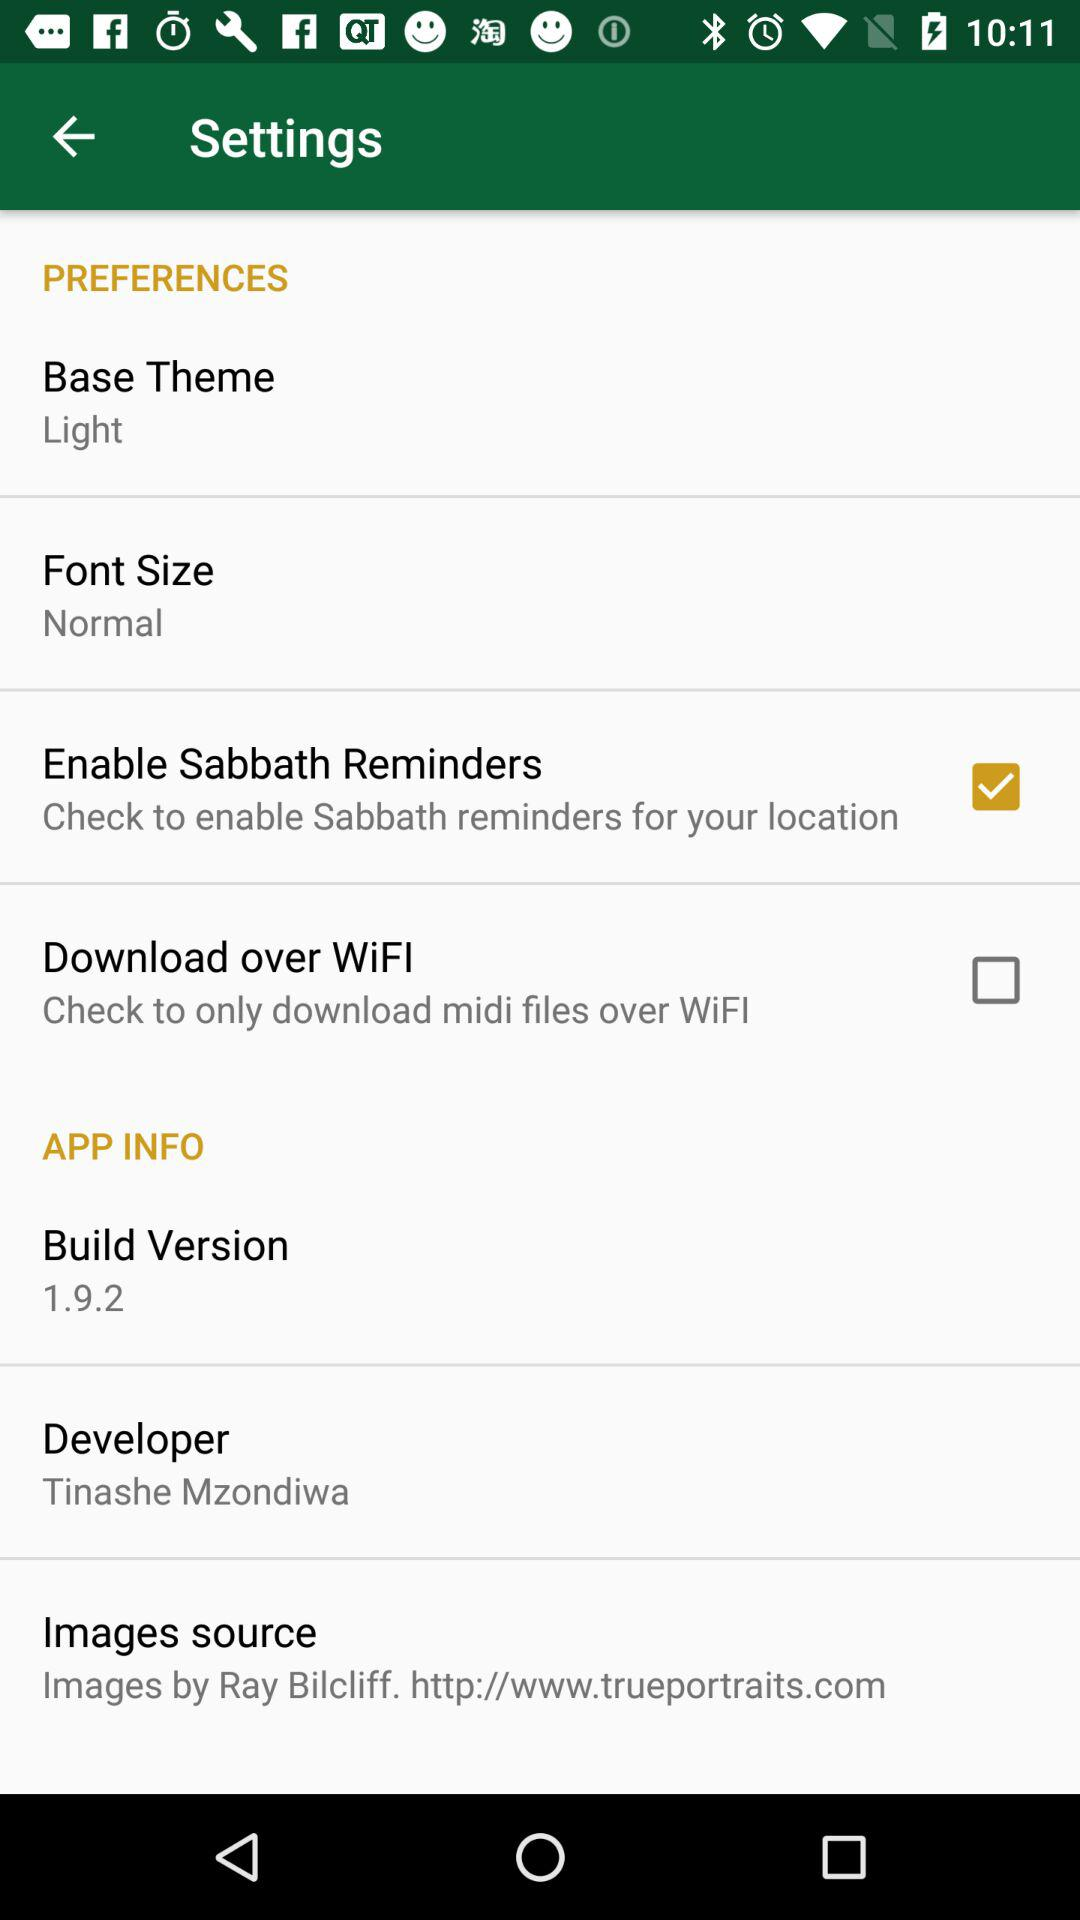What is the selected image source? The selected image source is "Images by Ray Bilcliff. http://www.trueportraits.com". 